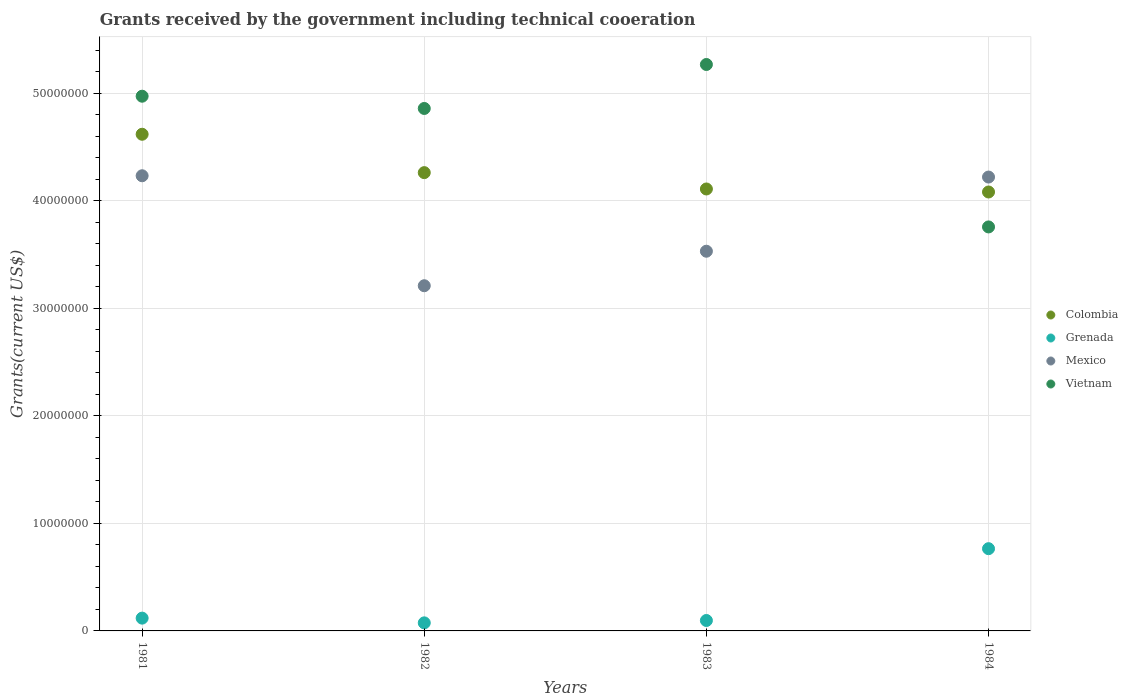How many different coloured dotlines are there?
Your answer should be compact. 4. Is the number of dotlines equal to the number of legend labels?
Offer a very short reply. Yes. What is the total grants received by the government in Vietnam in 1984?
Your answer should be very brief. 3.76e+07. Across all years, what is the maximum total grants received by the government in Mexico?
Provide a succinct answer. 4.23e+07. Across all years, what is the minimum total grants received by the government in Mexico?
Offer a terse response. 3.21e+07. In which year was the total grants received by the government in Vietnam minimum?
Offer a very short reply. 1984. What is the total total grants received by the government in Colombia in the graph?
Offer a terse response. 1.71e+08. What is the difference between the total grants received by the government in Vietnam in 1982 and that in 1983?
Ensure brevity in your answer.  -4.09e+06. What is the difference between the total grants received by the government in Colombia in 1984 and the total grants received by the government in Grenada in 1981?
Provide a short and direct response. 3.96e+07. What is the average total grants received by the government in Colombia per year?
Keep it short and to the point. 4.27e+07. In the year 1982, what is the difference between the total grants received by the government in Grenada and total grants received by the government in Colombia?
Ensure brevity in your answer.  -4.19e+07. In how many years, is the total grants received by the government in Colombia greater than 40000000 US$?
Your response must be concise. 4. What is the ratio of the total grants received by the government in Colombia in 1983 to that in 1984?
Offer a very short reply. 1.01. Is the total grants received by the government in Vietnam in 1983 less than that in 1984?
Provide a succinct answer. No. Is the difference between the total grants received by the government in Grenada in 1982 and 1984 greater than the difference between the total grants received by the government in Colombia in 1982 and 1984?
Keep it short and to the point. No. What is the difference between the highest and the second highest total grants received by the government in Grenada?
Offer a terse response. 6.46e+06. What is the difference between the highest and the lowest total grants received by the government in Colombia?
Offer a very short reply. 5.37e+06. In how many years, is the total grants received by the government in Mexico greater than the average total grants received by the government in Mexico taken over all years?
Give a very brief answer. 2. Is the sum of the total grants received by the government in Mexico in 1982 and 1983 greater than the maximum total grants received by the government in Grenada across all years?
Offer a terse response. Yes. Is it the case that in every year, the sum of the total grants received by the government in Vietnam and total grants received by the government in Colombia  is greater than the total grants received by the government in Grenada?
Offer a terse response. Yes. Does the total grants received by the government in Mexico monotonically increase over the years?
Your answer should be compact. No. Is the total grants received by the government in Vietnam strictly less than the total grants received by the government in Mexico over the years?
Make the answer very short. No. How many dotlines are there?
Ensure brevity in your answer.  4. How many years are there in the graph?
Your response must be concise. 4. What is the difference between two consecutive major ticks on the Y-axis?
Provide a short and direct response. 1.00e+07. Are the values on the major ticks of Y-axis written in scientific E-notation?
Offer a very short reply. No. Does the graph contain any zero values?
Make the answer very short. No. How many legend labels are there?
Provide a succinct answer. 4. What is the title of the graph?
Ensure brevity in your answer.  Grants received by the government including technical cooeration. What is the label or title of the X-axis?
Your response must be concise. Years. What is the label or title of the Y-axis?
Your response must be concise. Grants(current US$). What is the Grants(current US$) in Colombia in 1981?
Keep it short and to the point. 4.62e+07. What is the Grants(current US$) in Grenada in 1981?
Keep it short and to the point. 1.19e+06. What is the Grants(current US$) in Mexico in 1981?
Your answer should be compact. 4.23e+07. What is the Grants(current US$) in Vietnam in 1981?
Offer a very short reply. 4.97e+07. What is the Grants(current US$) of Colombia in 1982?
Your answer should be very brief. 4.26e+07. What is the Grants(current US$) in Grenada in 1982?
Provide a short and direct response. 7.50e+05. What is the Grants(current US$) in Mexico in 1982?
Keep it short and to the point. 3.21e+07. What is the Grants(current US$) of Vietnam in 1982?
Your response must be concise. 4.86e+07. What is the Grants(current US$) in Colombia in 1983?
Ensure brevity in your answer.  4.11e+07. What is the Grants(current US$) in Grenada in 1983?
Offer a very short reply. 9.70e+05. What is the Grants(current US$) of Mexico in 1983?
Provide a succinct answer. 3.53e+07. What is the Grants(current US$) in Vietnam in 1983?
Provide a short and direct response. 5.27e+07. What is the Grants(current US$) of Colombia in 1984?
Provide a short and direct response. 4.08e+07. What is the Grants(current US$) of Grenada in 1984?
Provide a succinct answer. 7.65e+06. What is the Grants(current US$) in Mexico in 1984?
Provide a succinct answer. 4.22e+07. What is the Grants(current US$) in Vietnam in 1984?
Provide a succinct answer. 3.76e+07. Across all years, what is the maximum Grants(current US$) in Colombia?
Keep it short and to the point. 4.62e+07. Across all years, what is the maximum Grants(current US$) in Grenada?
Offer a very short reply. 7.65e+06. Across all years, what is the maximum Grants(current US$) in Mexico?
Your answer should be compact. 4.23e+07. Across all years, what is the maximum Grants(current US$) of Vietnam?
Your answer should be very brief. 5.27e+07. Across all years, what is the minimum Grants(current US$) in Colombia?
Provide a succinct answer. 4.08e+07. Across all years, what is the minimum Grants(current US$) of Grenada?
Your response must be concise. 7.50e+05. Across all years, what is the minimum Grants(current US$) of Mexico?
Offer a very short reply. 3.21e+07. Across all years, what is the minimum Grants(current US$) in Vietnam?
Your answer should be compact. 3.76e+07. What is the total Grants(current US$) of Colombia in the graph?
Provide a succinct answer. 1.71e+08. What is the total Grants(current US$) of Grenada in the graph?
Offer a terse response. 1.06e+07. What is the total Grants(current US$) of Mexico in the graph?
Ensure brevity in your answer.  1.52e+08. What is the total Grants(current US$) of Vietnam in the graph?
Make the answer very short. 1.89e+08. What is the difference between the Grants(current US$) of Colombia in 1981 and that in 1982?
Make the answer very short. 3.57e+06. What is the difference between the Grants(current US$) in Grenada in 1981 and that in 1982?
Offer a very short reply. 4.40e+05. What is the difference between the Grants(current US$) of Mexico in 1981 and that in 1982?
Your answer should be very brief. 1.02e+07. What is the difference between the Grants(current US$) of Vietnam in 1981 and that in 1982?
Your answer should be compact. 1.14e+06. What is the difference between the Grants(current US$) in Colombia in 1981 and that in 1983?
Give a very brief answer. 5.09e+06. What is the difference between the Grants(current US$) in Grenada in 1981 and that in 1983?
Ensure brevity in your answer.  2.20e+05. What is the difference between the Grants(current US$) in Mexico in 1981 and that in 1983?
Give a very brief answer. 7.02e+06. What is the difference between the Grants(current US$) in Vietnam in 1981 and that in 1983?
Your answer should be compact. -2.95e+06. What is the difference between the Grants(current US$) of Colombia in 1981 and that in 1984?
Make the answer very short. 5.37e+06. What is the difference between the Grants(current US$) in Grenada in 1981 and that in 1984?
Give a very brief answer. -6.46e+06. What is the difference between the Grants(current US$) in Mexico in 1981 and that in 1984?
Your answer should be compact. 1.20e+05. What is the difference between the Grants(current US$) of Vietnam in 1981 and that in 1984?
Ensure brevity in your answer.  1.22e+07. What is the difference between the Grants(current US$) of Colombia in 1982 and that in 1983?
Keep it short and to the point. 1.52e+06. What is the difference between the Grants(current US$) in Grenada in 1982 and that in 1983?
Provide a short and direct response. -2.20e+05. What is the difference between the Grants(current US$) of Mexico in 1982 and that in 1983?
Your response must be concise. -3.21e+06. What is the difference between the Grants(current US$) in Vietnam in 1982 and that in 1983?
Offer a very short reply. -4.09e+06. What is the difference between the Grants(current US$) in Colombia in 1982 and that in 1984?
Your response must be concise. 1.80e+06. What is the difference between the Grants(current US$) in Grenada in 1982 and that in 1984?
Your answer should be compact. -6.90e+06. What is the difference between the Grants(current US$) of Mexico in 1982 and that in 1984?
Provide a succinct answer. -1.01e+07. What is the difference between the Grants(current US$) in Vietnam in 1982 and that in 1984?
Ensure brevity in your answer.  1.10e+07. What is the difference between the Grants(current US$) in Colombia in 1983 and that in 1984?
Provide a succinct answer. 2.80e+05. What is the difference between the Grants(current US$) of Grenada in 1983 and that in 1984?
Your response must be concise. -6.68e+06. What is the difference between the Grants(current US$) in Mexico in 1983 and that in 1984?
Offer a very short reply. -6.90e+06. What is the difference between the Grants(current US$) of Vietnam in 1983 and that in 1984?
Offer a very short reply. 1.51e+07. What is the difference between the Grants(current US$) in Colombia in 1981 and the Grants(current US$) in Grenada in 1982?
Your answer should be compact. 4.54e+07. What is the difference between the Grants(current US$) in Colombia in 1981 and the Grants(current US$) in Mexico in 1982?
Offer a terse response. 1.41e+07. What is the difference between the Grants(current US$) in Colombia in 1981 and the Grants(current US$) in Vietnam in 1982?
Your answer should be very brief. -2.40e+06. What is the difference between the Grants(current US$) of Grenada in 1981 and the Grants(current US$) of Mexico in 1982?
Your answer should be very brief. -3.09e+07. What is the difference between the Grants(current US$) in Grenada in 1981 and the Grants(current US$) in Vietnam in 1982?
Keep it short and to the point. -4.74e+07. What is the difference between the Grants(current US$) of Mexico in 1981 and the Grants(current US$) of Vietnam in 1982?
Give a very brief answer. -6.26e+06. What is the difference between the Grants(current US$) in Colombia in 1981 and the Grants(current US$) in Grenada in 1983?
Offer a terse response. 4.52e+07. What is the difference between the Grants(current US$) in Colombia in 1981 and the Grants(current US$) in Mexico in 1983?
Make the answer very short. 1.09e+07. What is the difference between the Grants(current US$) in Colombia in 1981 and the Grants(current US$) in Vietnam in 1983?
Keep it short and to the point. -6.49e+06. What is the difference between the Grants(current US$) in Grenada in 1981 and the Grants(current US$) in Mexico in 1983?
Give a very brief answer. -3.41e+07. What is the difference between the Grants(current US$) in Grenada in 1981 and the Grants(current US$) in Vietnam in 1983?
Offer a terse response. -5.15e+07. What is the difference between the Grants(current US$) of Mexico in 1981 and the Grants(current US$) of Vietnam in 1983?
Give a very brief answer. -1.04e+07. What is the difference between the Grants(current US$) in Colombia in 1981 and the Grants(current US$) in Grenada in 1984?
Your answer should be compact. 3.86e+07. What is the difference between the Grants(current US$) of Colombia in 1981 and the Grants(current US$) of Mexico in 1984?
Give a very brief answer. 3.98e+06. What is the difference between the Grants(current US$) of Colombia in 1981 and the Grants(current US$) of Vietnam in 1984?
Ensure brevity in your answer.  8.62e+06. What is the difference between the Grants(current US$) of Grenada in 1981 and the Grants(current US$) of Mexico in 1984?
Offer a terse response. -4.10e+07. What is the difference between the Grants(current US$) of Grenada in 1981 and the Grants(current US$) of Vietnam in 1984?
Your answer should be very brief. -3.64e+07. What is the difference between the Grants(current US$) in Mexico in 1981 and the Grants(current US$) in Vietnam in 1984?
Offer a terse response. 4.76e+06. What is the difference between the Grants(current US$) in Colombia in 1982 and the Grants(current US$) in Grenada in 1983?
Your answer should be compact. 4.17e+07. What is the difference between the Grants(current US$) of Colombia in 1982 and the Grants(current US$) of Mexico in 1983?
Make the answer very short. 7.31e+06. What is the difference between the Grants(current US$) of Colombia in 1982 and the Grants(current US$) of Vietnam in 1983?
Your answer should be very brief. -1.01e+07. What is the difference between the Grants(current US$) in Grenada in 1982 and the Grants(current US$) in Mexico in 1983?
Make the answer very short. -3.46e+07. What is the difference between the Grants(current US$) in Grenada in 1982 and the Grants(current US$) in Vietnam in 1983?
Offer a very short reply. -5.19e+07. What is the difference between the Grants(current US$) of Mexico in 1982 and the Grants(current US$) of Vietnam in 1983?
Give a very brief answer. -2.06e+07. What is the difference between the Grants(current US$) in Colombia in 1982 and the Grants(current US$) in Grenada in 1984?
Offer a terse response. 3.50e+07. What is the difference between the Grants(current US$) in Colombia in 1982 and the Grants(current US$) in Mexico in 1984?
Your answer should be compact. 4.10e+05. What is the difference between the Grants(current US$) of Colombia in 1982 and the Grants(current US$) of Vietnam in 1984?
Make the answer very short. 5.05e+06. What is the difference between the Grants(current US$) in Grenada in 1982 and the Grants(current US$) in Mexico in 1984?
Keep it short and to the point. -4.15e+07. What is the difference between the Grants(current US$) in Grenada in 1982 and the Grants(current US$) in Vietnam in 1984?
Provide a short and direct response. -3.68e+07. What is the difference between the Grants(current US$) of Mexico in 1982 and the Grants(current US$) of Vietnam in 1984?
Your answer should be compact. -5.47e+06. What is the difference between the Grants(current US$) in Colombia in 1983 and the Grants(current US$) in Grenada in 1984?
Provide a succinct answer. 3.35e+07. What is the difference between the Grants(current US$) of Colombia in 1983 and the Grants(current US$) of Mexico in 1984?
Ensure brevity in your answer.  -1.11e+06. What is the difference between the Grants(current US$) in Colombia in 1983 and the Grants(current US$) in Vietnam in 1984?
Provide a succinct answer. 3.53e+06. What is the difference between the Grants(current US$) in Grenada in 1983 and the Grants(current US$) in Mexico in 1984?
Offer a terse response. -4.12e+07. What is the difference between the Grants(current US$) in Grenada in 1983 and the Grants(current US$) in Vietnam in 1984?
Your answer should be compact. -3.66e+07. What is the difference between the Grants(current US$) in Mexico in 1983 and the Grants(current US$) in Vietnam in 1984?
Keep it short and to the point. -2.26e+06. What is the average Grants(current US$) in Colombia per year?
Make the answer very short. 4.27e+07. What is the average Grants(current US$) of Grenada per year?
Give a very brief answer. 2.64e+06. What is the average Grants(current US$) of Mexico per year?
Offer a very short reply. 3.80e+07. What is the average Grants(current US$) of Vietnam per year?
Keep it short and to the point. 4.72e+07. In the year 1981, what is the difference between the Grants(current US$) in Colombia and Grants(current US$) in Grenada?
Your answer should be very brief. 4.50e+07. In the year 1981, what is the difference between the Grants(current US$) in Colombia and Grants(current US$) in Mexico?
Make the answer very short. 3.86e+06. In the year 1981, what is the difference between the Grants(current US$) in Colombia and Grants(current US$) in Vietnam?
Your response must be concise. -3.54e+06. In the year 1981, what is the difference between the Grants(current US$) in Grenada and Grants(current US$) in Mexico?
Offer a very short reply. -4.12e+07. In the year 1981, what is the difference between the Grants(current US$) in Grenada and Grants(current US$) in Vietnam?
Offer a terse response. -4.86e+07. In the year 1981, what is the difference between the Grants(current US$) of Mexico and Grants(current US$) of Vietnam?
Your answer should be compact. -7.40e+06. In the year 1982, what is the difference between the Grants(current US$) in Colombia and Grants(current US$) in Grenada?
Offer a very short reply. 4.19e+07. In the year 1982, what is the difference between the Grants(current US$) in Colombia and Grants(current US$) in Mexico?
Your response must be concise. 1.05e+07. In the year 1982, what is the difference between the Grants(current US$) of Colombia and Grants(current US$) of Vietnam?
Make the answer very short. -5.97e+06. In the year 1982, what is the difference between the Grants(current US$) in Grenada and Grants(current US$) in Mexico?
Offer a very short reply. -3.14e+07. In the year 1982, what is the difference between the Grants(current US$) of Grenada and Grants(current US$) of Vietnam?
Your answer should be very brief. -4.78e+07. In the year 1982, what is the difference between the Grants(current US$) of Mexico and Grants(current US$) of Vietnam?
Provide a succinct answer. -1.65e+07. In the year 1983, what is the difference between the Grants(current US$) of Colombia and Grants(current US$) of Grenada?
Your response must be concise. 4.01e+07. In the year 1983, what is the difference between the Grants(current US$) in Colombia and Grants(current US$) in Mexico?
Offer a terse response. 5.79e+06. In the year 1983, what is the difference between the Grants(current US$) of Colombia and Grants(current US$) of Vietnam?
Provide a succinct answer. -1.16e+07. In the year 1983, what is the difference between the Grants(current US$) in Grenada and Grants(current US$) in Mexico?
Provide a short and direct response. -3.44e+07. In the year 1983, what is the difference between the Grants(current US$) of Grenada and Grants(current US$) of Vietnam?
Provide a succinct answer. -5.17e+07. In the year 1983, what is the difference between the Grants(current US$) in Mexico and Grants(current US$) in Vietnam?
Ensure brevity in your answer.  -1.74e+07. In the year 1984, what is the difference between the Grants(current US$) of Colombia and Grants(current US$) of Grenada?
Your answer should be compact. 3.32e+07. In the year 1984, what is the difference between the Grants(current US$) of Colombia and Grants(current US$) of Mexico?
Offer a very short reply. -1.39e+06. In the year 1984, what is the difference between the Grants(current US$) in Colombia and Grants(current US$) in Vietnam?
Your answer should be very brief. 3.25e+06. In the year 1984, what is the difference between the Grants(current US$) in Grenada and Grants(current US$) in Mexico?
Make the answer very short. -3.46e+07. In the year 1984, what is the difference between the Grants(current US$) of Grenada and Grants(current US$) of Vietnam?
Your answer should be very brief. -2.99e+07. In the year 1984, what is the difference between the Grants(current US$) in Mexico and Grants(current US$) in Vietnam?
Ensure brevity in your answer.  4.64e+06. What is the ratio of the Grants(current US$) in Colombia in 1981 to that in 1982?
Your answer should be very brief. 1.08. What is the ratio of the Grants(current US$) of Grenada in 1981 to that in 1982?
Your answer should be very brief. 1.59. What is the ratio of the Grants(current US$) of Mexico in 1981 to that in 1982?
Your response must be concise. 1.32. What is the ratio of the Grants(current US$) in Vietnam in 1981 to that in 1982?
Provide a succinct answer. 1.02. What is the ratio of the Grants(current US$) in Colombia in 1981 to that in 1983?
Offer a very short reply. 1.12. What is the ratio of the Grants(current US$) of Grenada in 1981 to that in 1983?
Give a very brief answer. 1.23. What is the ratio of the Grants(current US$) in Mexico in 1981 to that in 1983?
Make the answer very short. 1.2. What is the ratio of the Grants(current US$) in Vietnam in 1981 to that in 1983?
Give a very brief answer. 0.94. What is the ratio of the Grants(current US$) of Colombia in 1981 to that in 1984?
Give a very brief answer. 1.13. What is the ratio of the Grants(current US$) in Grenada in 1981 to that in 1984?
Your answer should be compact. 0.16. What is the ratio of the Grants(current US$) of Mexico in 1981 to that in 1984?
Provide a short and direct response. 1. What is the ratio of the Grants(current US$) in Vietnam in 1981 to that in 1984?
Your answer should be compact. 1.32. What is the ratio of the Grants(current US$) in Colombia in 1982 to that in 1983?
Your response must be concise. 1.04. What is the ratio of the Grants(current US$) of Grenada in 1982 to that in 1983?
Offer a very short reply. 0.77. What is the ratio of the Grants(current US$) of Mexico in 1982 to that in 1983?
Provide a succinct answer. 0.91. What is the ratio of the Grants(current US$) of Vietnam in 1982 to that in 1983?
Ensure brevity in your answer.  0.92. What is the ratio of the Grants(current US$) of Colombia in 1982 to that in 1984?
Keep it short and to the point. 1.04. What is the ratio of the Grants(current US$) of Grenada in 1982 to that in 1984?
Offer a very short reply. 0.1. What is the ratio of the Grants(current US$) in Mexico in 1982 to that in 1984?
Provide a short and direct response. 0.76. What is the ratio of the Grants(current US$) of Vietnam in 1982 to that in 1984?
Your answer should be compact. 1.29. What is the ratio of the Grants(current US$) in Grenada in 1983 to that in 1984?
Your answer should be compact. 0.13. What is the ratio of the Grants(current US$) of Mexico in 1983 to that in 1984?
Offer a very short reply. 0.84. What is the ratio of the Grants(current US$) of Vietnam in 1983 to that in 1984?
Provide a succinct answer. 1.4. What is the difference between the highest and the second highest Grants(current US$) of Colombia?
Your answer should be very brief. 3.57e+06. What is the difference between the highest and the second highest Grants(current US$) of Grenada?
Provide a short and direct response. 6.46e+06. What is the difference between the highest and the second highest Grants(current US$) in Vietnam?
Your response must be concise. 2.95e+06. What is the difference between the highest and the lowest Grants(current US$) in Colombia?
Offer a very short reply. 5.37e+06. What is the difference between the highest and the lowest Grants(current US$) in Grenada?
Ensure brevity in your answer.  6.90e+06. What is the difference between the highest and the lowest Grants(current US$) of Mexico?
Your answer should be compact. 1.02e+07. What is the difference between the highest and the lowest Grants(current US$) in Vietnam?
Your answer should be very brief. 1.51e+07. 